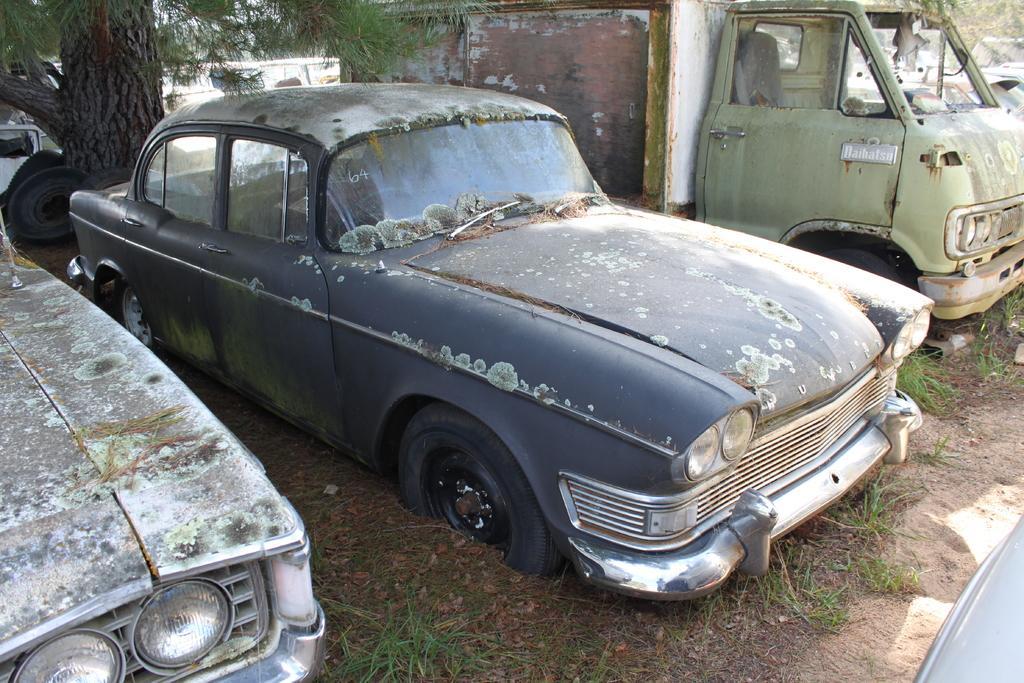Could you give a brief overview of what you see in this image? In this image, we can see few vehicles. At the bottom, we can see the ground, grass and dry leaves. On the left side top of the image, we can see the tree trunk. 